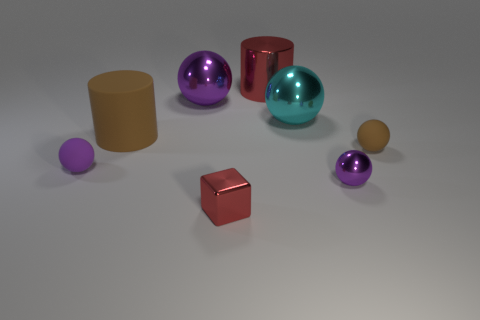There is a purple matte object; is its size the same as the brown thing that is right of the large rubber cylinder?
Keep it short and to the point. Yes. There is a ball that is on the left side of the brown cylinder; is there a small rubber sphere that is right of it?
Ensure brevity in your answer.  Yes. What shape is the red metal object right of the small red metal cube?
Offer a very short reply. Cylinder. What is the material of the cylinder that is the same color as the cube?
Ensure brevity in your answer.  Metal. There is a big cylinder left of the red shiny thing that is right of the metallic cube; what color is it?
Keep it short and to the point. Brown. Is the size of the red shiny cylinder the same as the brown ball?
Your answer should be compact. No. What is the material of the brown thing that is the same shape as the big cyan shiny object?
Keep it short and to the point. Rubber. How many cyan matte cubes are the same size as the matte cylinder?
Offer a terse response. 0. There is a large cylinder that is the same material as the tiny brown ball; what color is it?
Your answer should be very brief. Brown. Is the number of large purple shiny spheres less than the number of small blue rubber spheres?
Make the answer very short. No. 